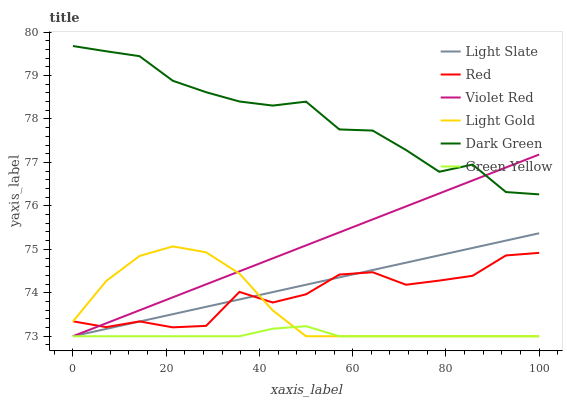Does Green Yellow have the minimum area under the curve?
Answer yes or no. Yes. Does Dark Green have the maximum area under the curve?
Answer yes or no. Yes. Does Light Slate have the minimum area under the curve?
Answer yes or no. No. Does Light Slate have the maximum area under the curve?
Answer yes or no. No. Is Light Slate the smoothest?
Answer yes or no. Yes. Is Red the roughest?
Answer yes or no. Yes. Is Green Yellow the smoothest?
Answer yes or no. No. Is Green Yellow the roughest?
Answer yes or no. No. Does Violet Red have the lowest value?
Answer yes or no. Yes. Does Red have the lowest value?
Answer yes or no. No. Does Dark Green have the highest value?
Answer yes or no. Yes. Does Light Slate have the highest value?
Answer yes or no. No. Is Green Yellow less than Dark Green?
Answer yes or no. Yes. Is Dark Green greater than Green Yellow?
Answer yes or no. Yes. Does Red intersect Violet Red?
Answer yes or no. Yes. Is Red less than Violet Red?
Answer yes or no. No. Is Red greater than Violet Red?
Answer yes or no. No. Does Green Yellow intersect Dark Green?
Answer yes or no. No. 